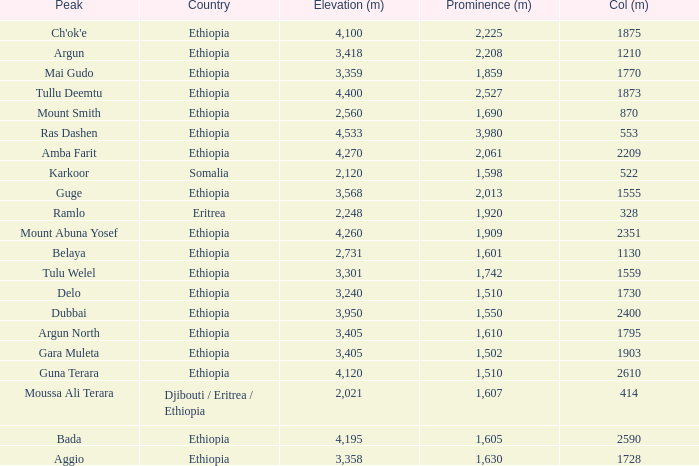What is the total prominence number in m of ethiopia, which has a col in m of 1728 and an elevation less than 3,358? 0.0. 